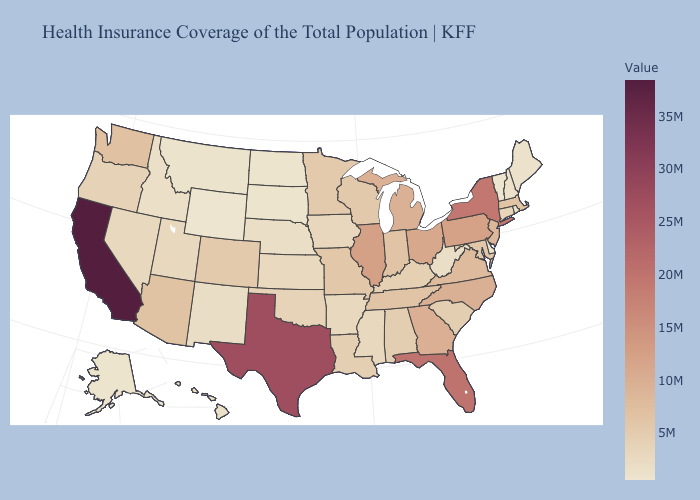Does Delaware have the lowest value in the USA?
Concise answer only. No. Which states have the lowest value in the USA?
Write a very short answer. Wyoming. Is the legend a continuous bar?
Write a very short answer. Yes. Which states have the lowest value in the USA?
Be succinct. Wyoming. Does North Dakota have a higher value than Maryland?
Answer briefly. No. 